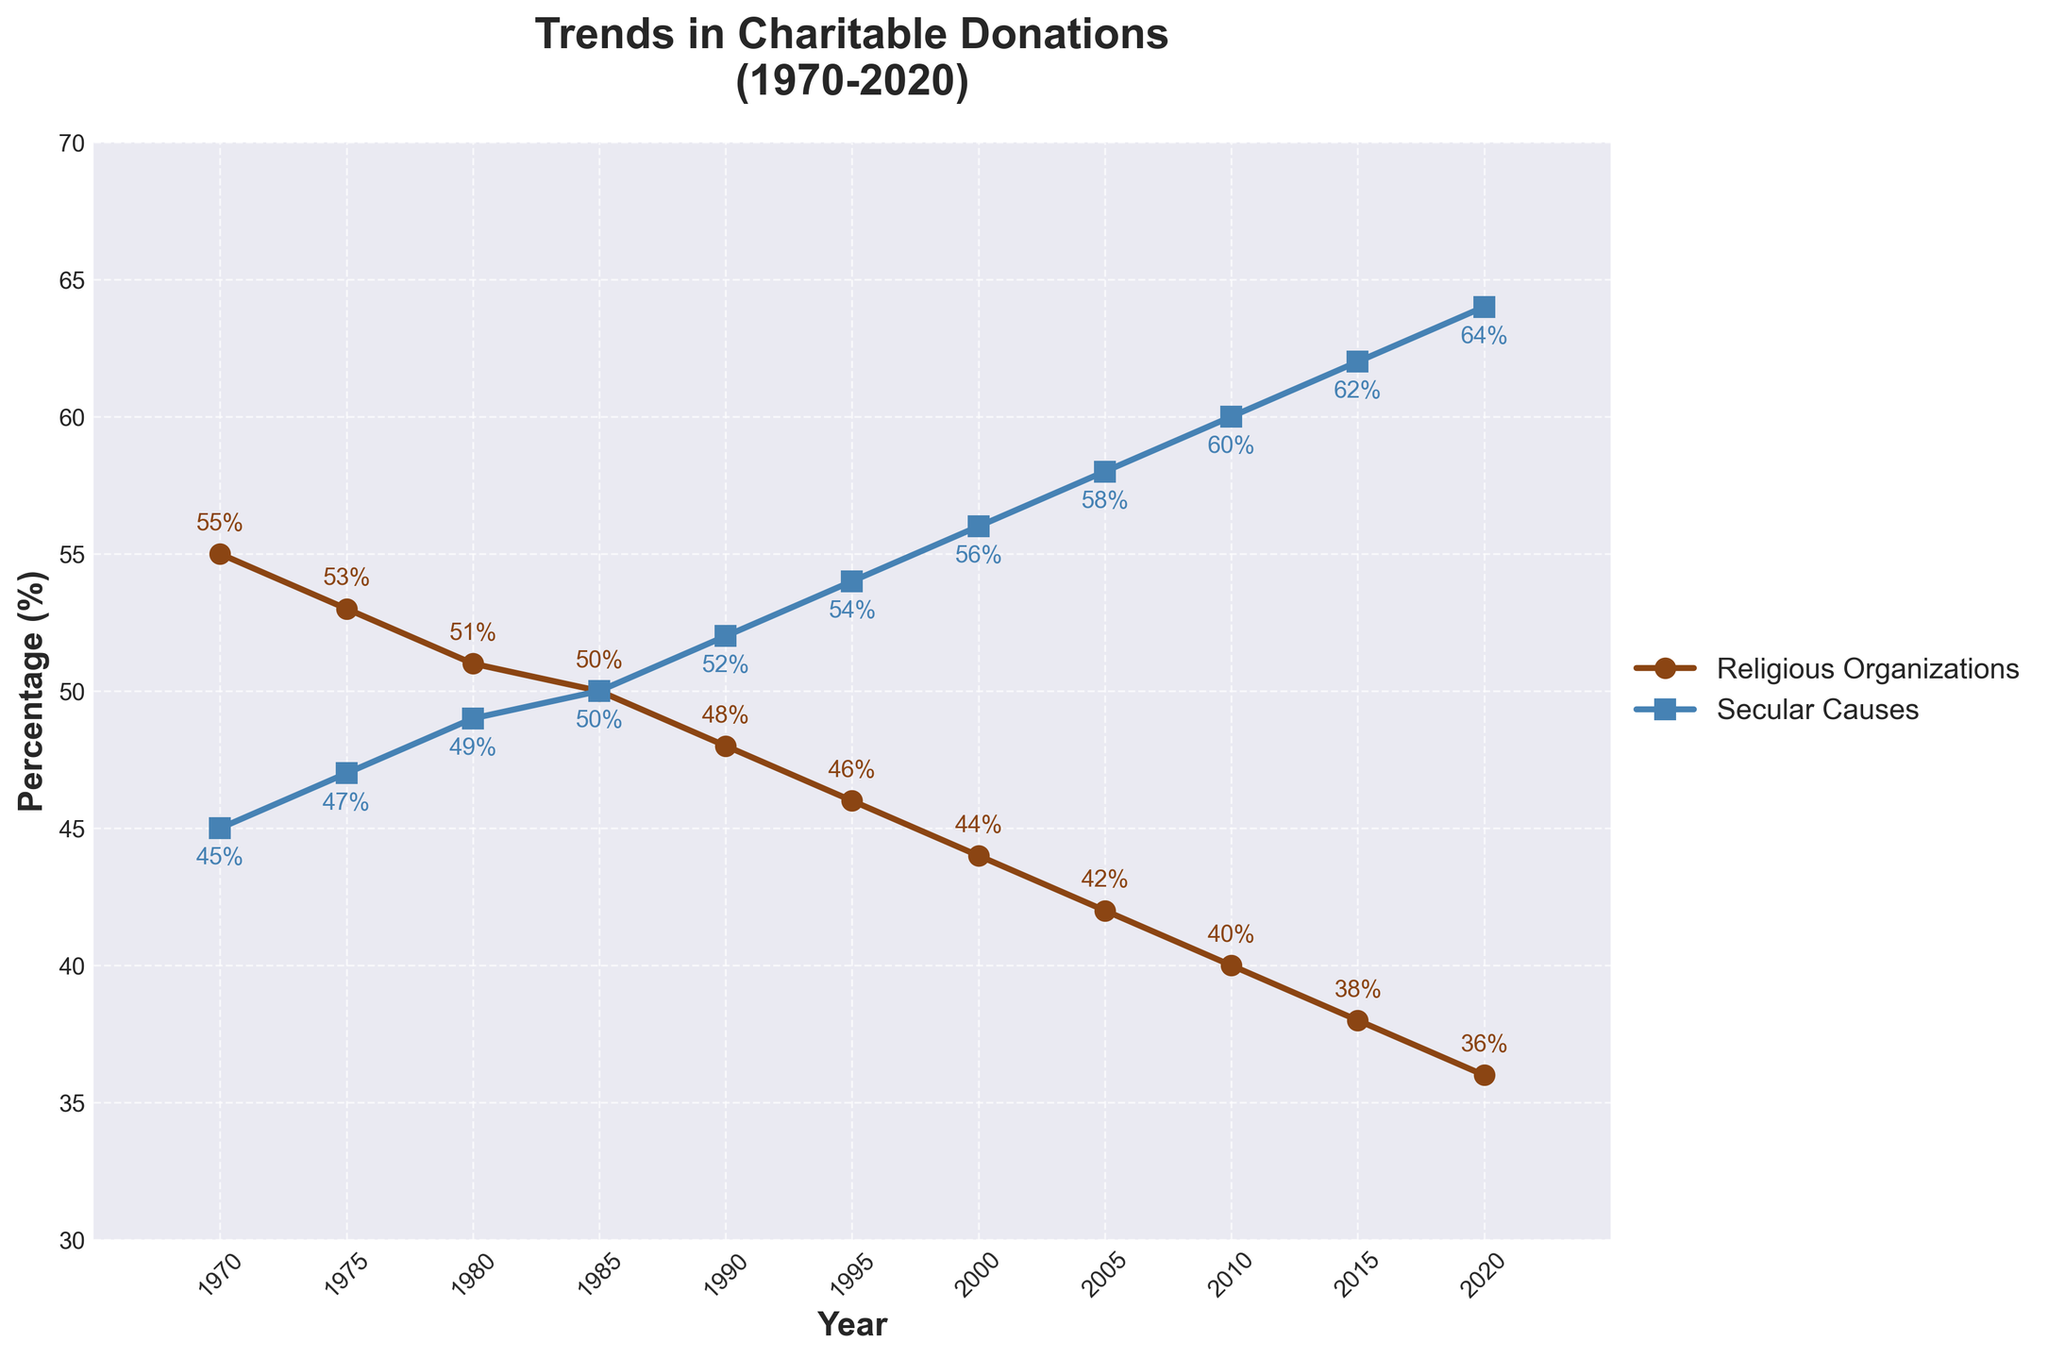What is the percentage of donations to religious organizations in 1970? Referring to the figure, look at the data point on the line representing religious organizations for the year 1970. The marker there indicates 55%.
Answer: 55% How has the percentage of donations to secular causes changed from 1980 to 2020? To find this, identify the percentages on the secular causes line for 1980 and 2020, which are 49% and 64%, respectively. Calculate the difference: 64% - 49% = 15%.
Answer: Increased by 15% Which year did the percentage of donations to secular causes equal that to religious organizations? Look for the point where the two lines intersect. It is in 1985, where both lines share the same value of 50%.
Answer: 1985 In which year did donations to secular causes surpass those to religious organizations? Compare the two lines and find the first year after 1985 where the secular causes line is above the religious organizations line. This occurs in 1990.
Answer: 1990 What's the average percentage of donations to religious organizations over the 50-year period? To find the average, sum all the given percentages for religious organizations (55 + 53 + 51 + 50 + 48 + 46 + 44 + 42 + 40 + 38 + 36) and divide by the number of data points, which is 11. (553 / 11)
Answer: 50.27% Identify the year with the steepest decline in donations to religious organizations. Analyze the slopes of the line segments for religious organizations. The steepest decline occurs between 2015 and 2020, where the percentage drops from 38% to 36%.
Answer: 2015-2020 Which cause (religious or secular) shows a more consistent trend over time? By visually inspecting the lines, secular causes show a consistently increasing trend, while religious organizations show a consistent decline. Both trends appear consistent but in opposite directions.
Answer: Both consistent, opposite trends What is the difference in donations to religious organizations between 1970 and 2020? Identify the percentages for religious organizations in these years, 55% (1970) and 36% (2020). Calculate the difference: 55% - 36% = 19%.
Answer: 19% How much did the donation percentage to secular causes increase from 2000 to 2010? Find the values for secular causes in 2000 (56%) and 2010 (60%). Subtract the older value from the newer one: 60% - 56% = 4%.
Answer: Increased by 4% What is the trend in the gap between donations to religious organizations and secular causes from 1970 to 2020? The gap clearly widens over time, as the religious donation percentage decreases and the secular donation percentage increases. For example, in 1970 the gap was 10% (55% - 45% = 10%) and it increased to 28% by 2020 (64% - 36% = 28%).
Answer: Widening gap up to 28% in 2020 